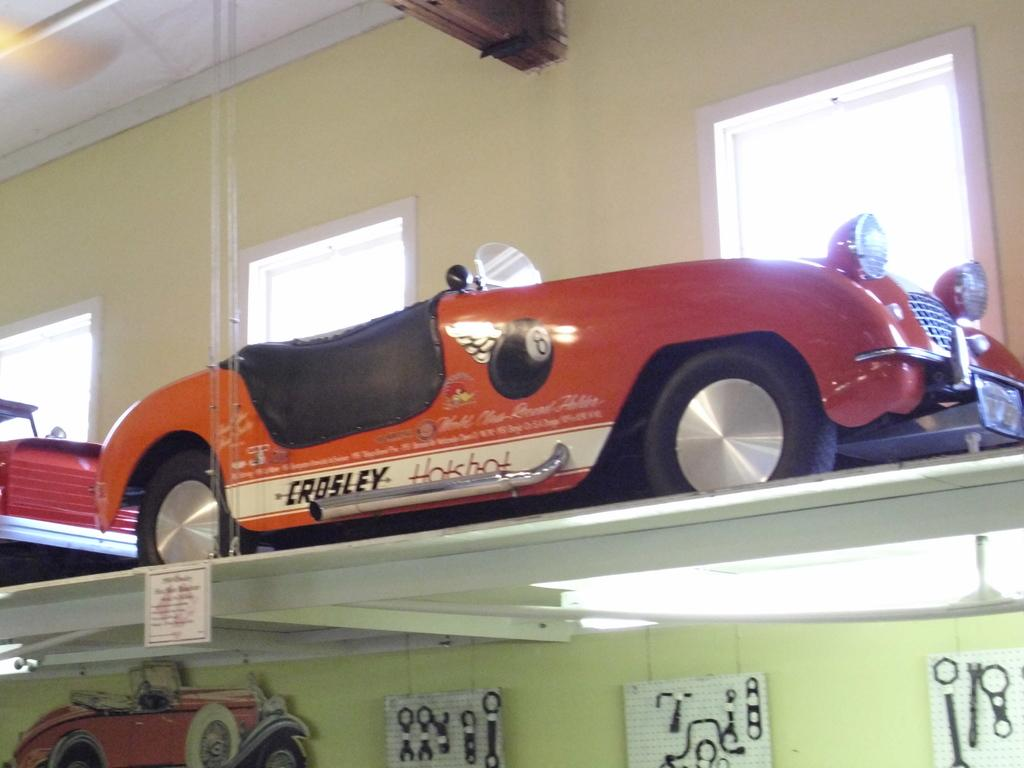What type of objects are on the shelf in the image? There are toy vehicles on a shelf in the image. What can be seen on the wall in the image? There are posters on the wall in the image. What is the purpose of the name board in the image? The name board in the image is likely used for identification or labeling purposes. What can be seen in the background of the image? Windows and the ceiling are visible in the background of the image. Can you describe the beam that the donkey is carrying in the image? There is no donkey or beam present in the image; it features toy vehicles, posters, a name board, windows, and a ceiling. What type of table is visible in the image? There is no table visible in the image. 